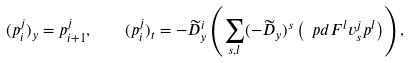<formula> <loc_0><loc_0><loc_500><loc_500>( p ^ { j } _ { i } ) _ { y } = p ^ { j } _ { i + 1 } , \quad ( p ^ { j } _ { i } ) _ { t } = - \widetilde { D } _ { y } ^ { i } \left ( \sum _ { s , l } ( - \widetilde { D } _ { y } ) ^ { s } \left ( \ p d { F ^ { l } } { v ^ { j } _ { s } } p ^ { l } \right ) \right ) ,</formula> 